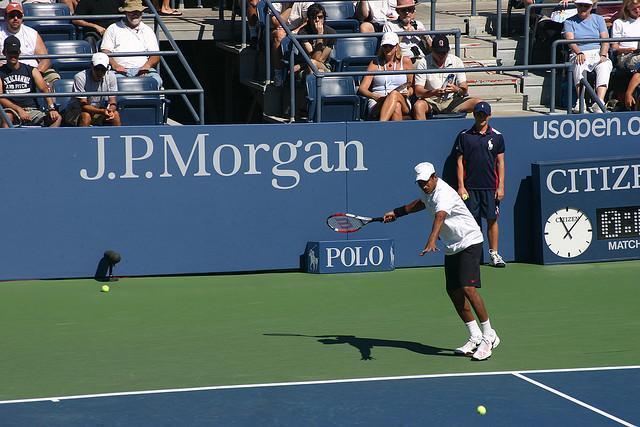What is the finance company advertised on the wall next to the tennis player?
Choose the right answer from the provided options to respond to the question.
Options: Jp morgan, etrade, wells fargo, ameritrade. Jp morgan. 